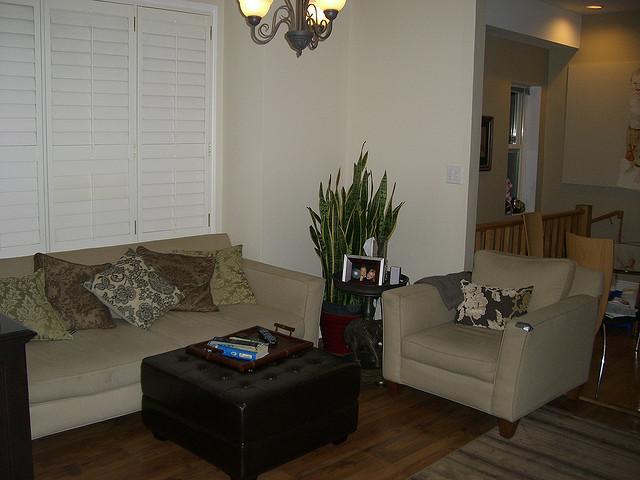Are the curtains open?
Concise answer only. No. Where are the artificial flowers?
Concise answer only. In pot. How many pictures in the photo?
Write a very short answer. 1. How many pillows in the chair on the right?
Give a very brief answer. 1. Is there a view of the outdoors?
Short answer required. No. Would sitting on the coffee table be a good idea?
Quick response, please. No. How many chairs do you see?
Answer briefly. 3. Is this a museum?
Write a very short answer. No. What is on the ottoman?
Give a very brief answer. Tray. Is the window open?
Short answer required. No. What is the color of the couch?
Answer briefly. Beige. Does this room have a lot of natural light?
Keep it brief. No. Is this a hotel?
Concise answer only. No. How many people can you see in the picture?
Short answer required. 0. What is this piece of furniture made of?
Be succinct. Leather. What is on the table?
Keep it brief. Books. Is there a power strip on the floor?
Short answer required. No. 